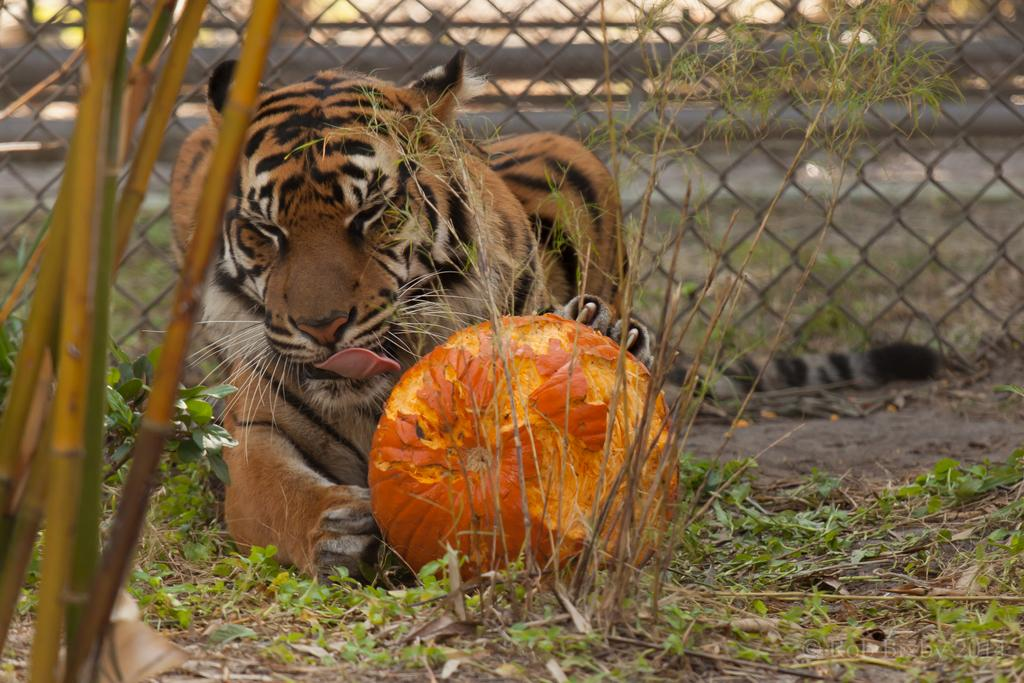What animal is holding a pumpkin in the image? There is a tiger holding a pumpkin in the image. What type of vegetation is present in the image? There are plants in the image. What structures can be seen in the image? There are poles and a fence in the image. What type of owl can be seen working on the fence in the image? There is no owl present in the image, and no one is working on the fence. 